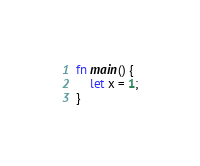Convert code to text. <code><loc_0><loc_0><loc_500><loc_500><_Rust_>fn main() {
    let x = 1;
}
</code> 